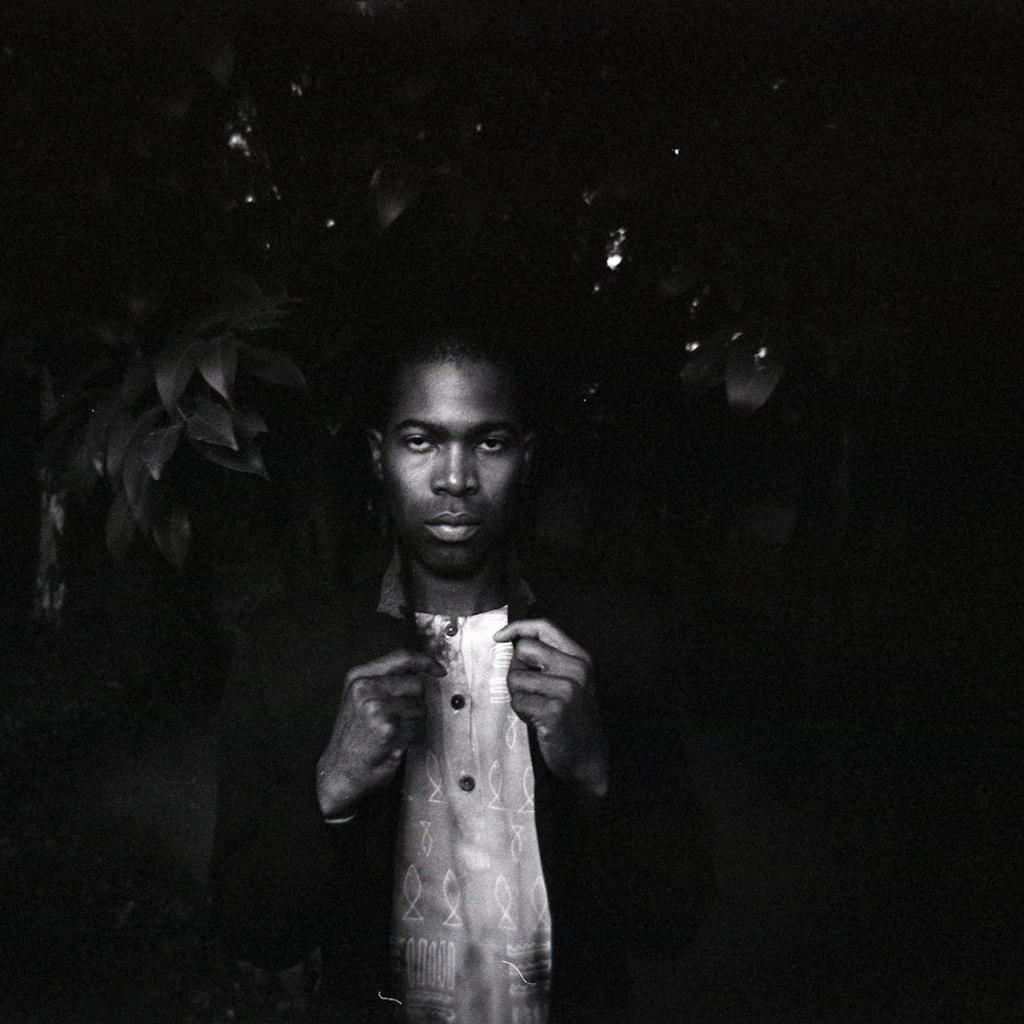Describe this image in one or two sentences. This is black and white images, we can see a person, tree, and the dark background. 